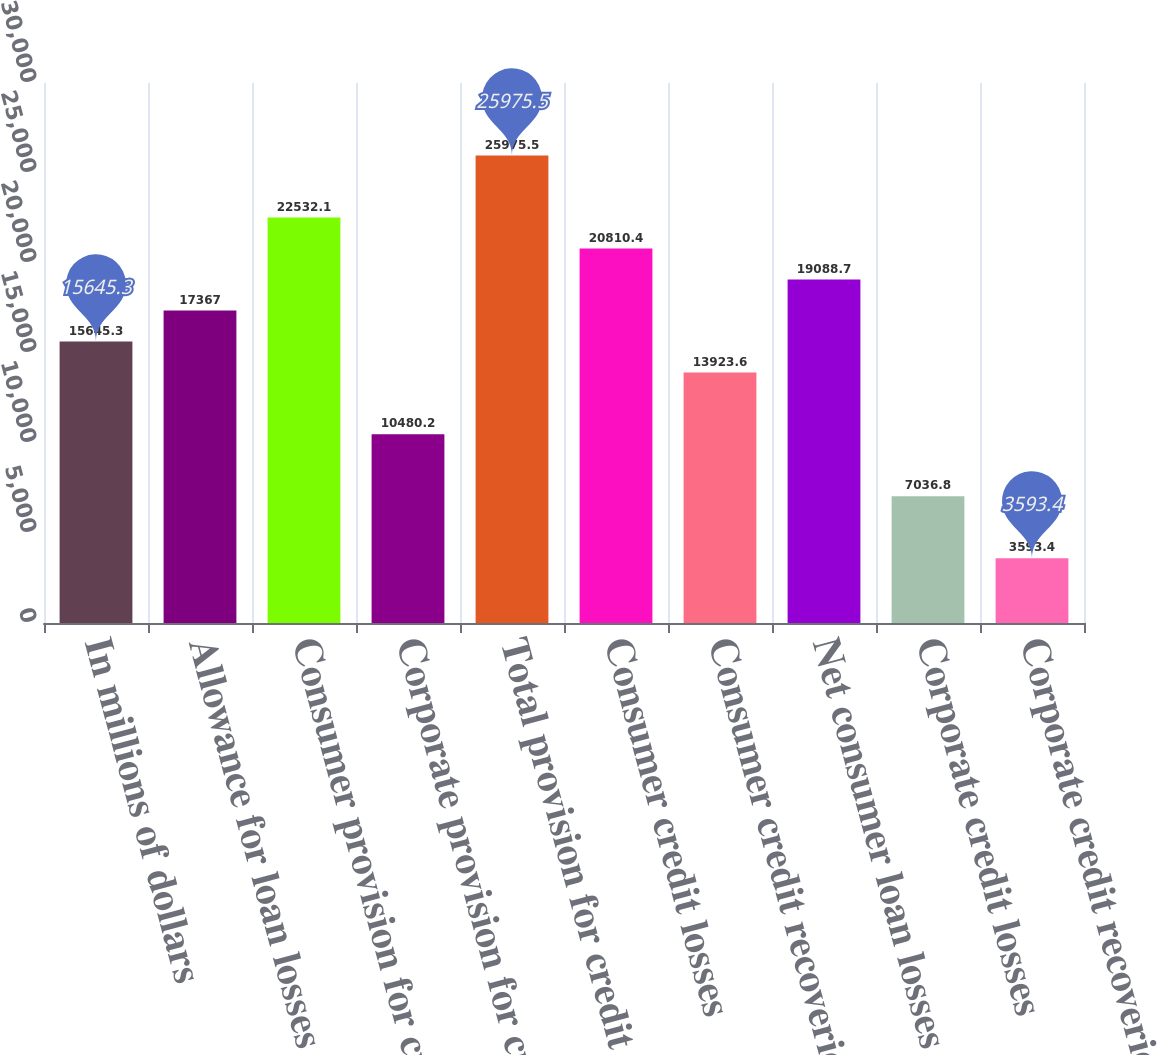Convert chart to OTSL. <chart><loc_0><loc_0><loc_500><loc_500><bar_chart><fcel>In millions of dollars<fcel>Allowance for loan losses at<fcel>Consumer provision for credit<fcel>Corporate provision for credit<fcel>Total provision for credit<fcel>Consumer credit losses<fcel>Consumer credit recoveries<fcel>Net consumer loan losses<fcel>Corporate credit losses<fcel>Corporate credit recoveries<nl><fcel>15645.3<fcel>17367<fcel>22532.1<fcel>10480.2<fcel>25975.5<fcel>20810.4<fcel>13923.6<fcel>19088.7<fcel>7036.8<fcel>3593.4<nl></chart> 